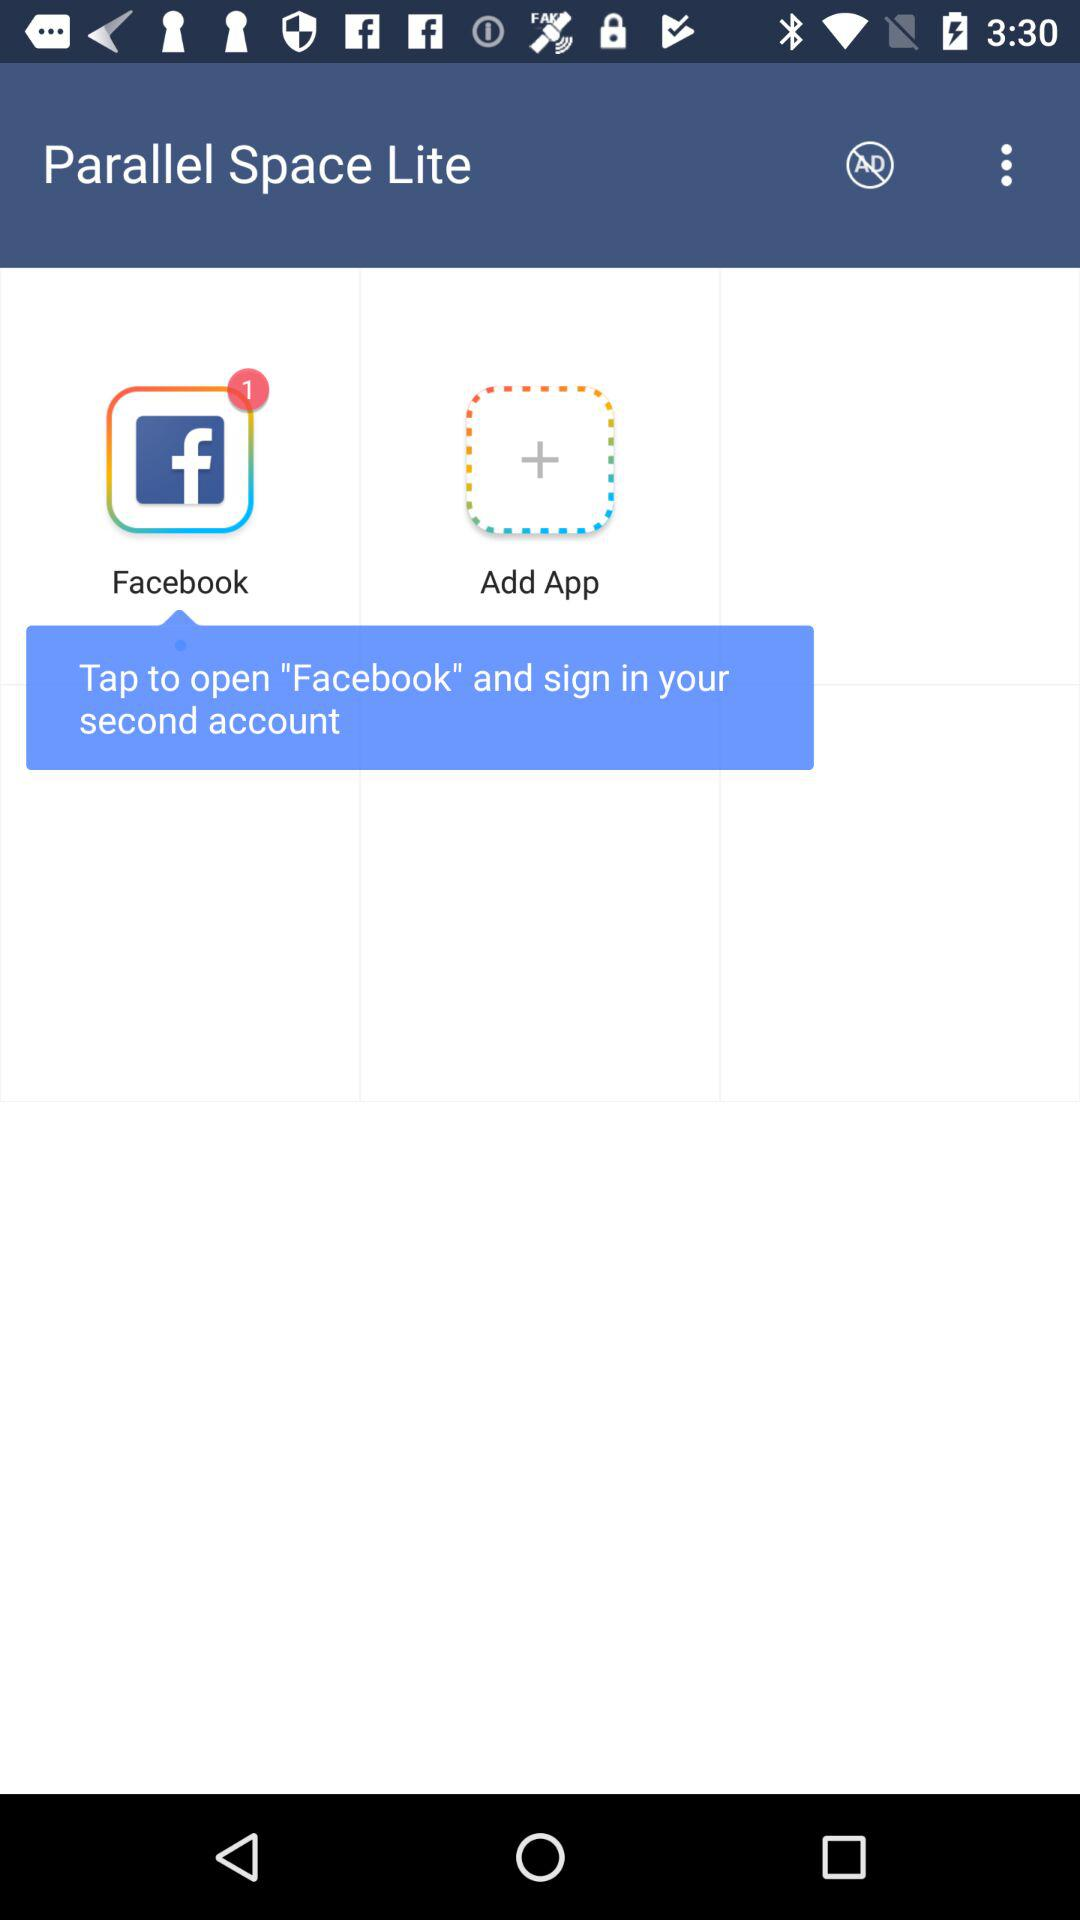How to sign in to a second account? To sign in to a second account, tap to open "Facebook". 